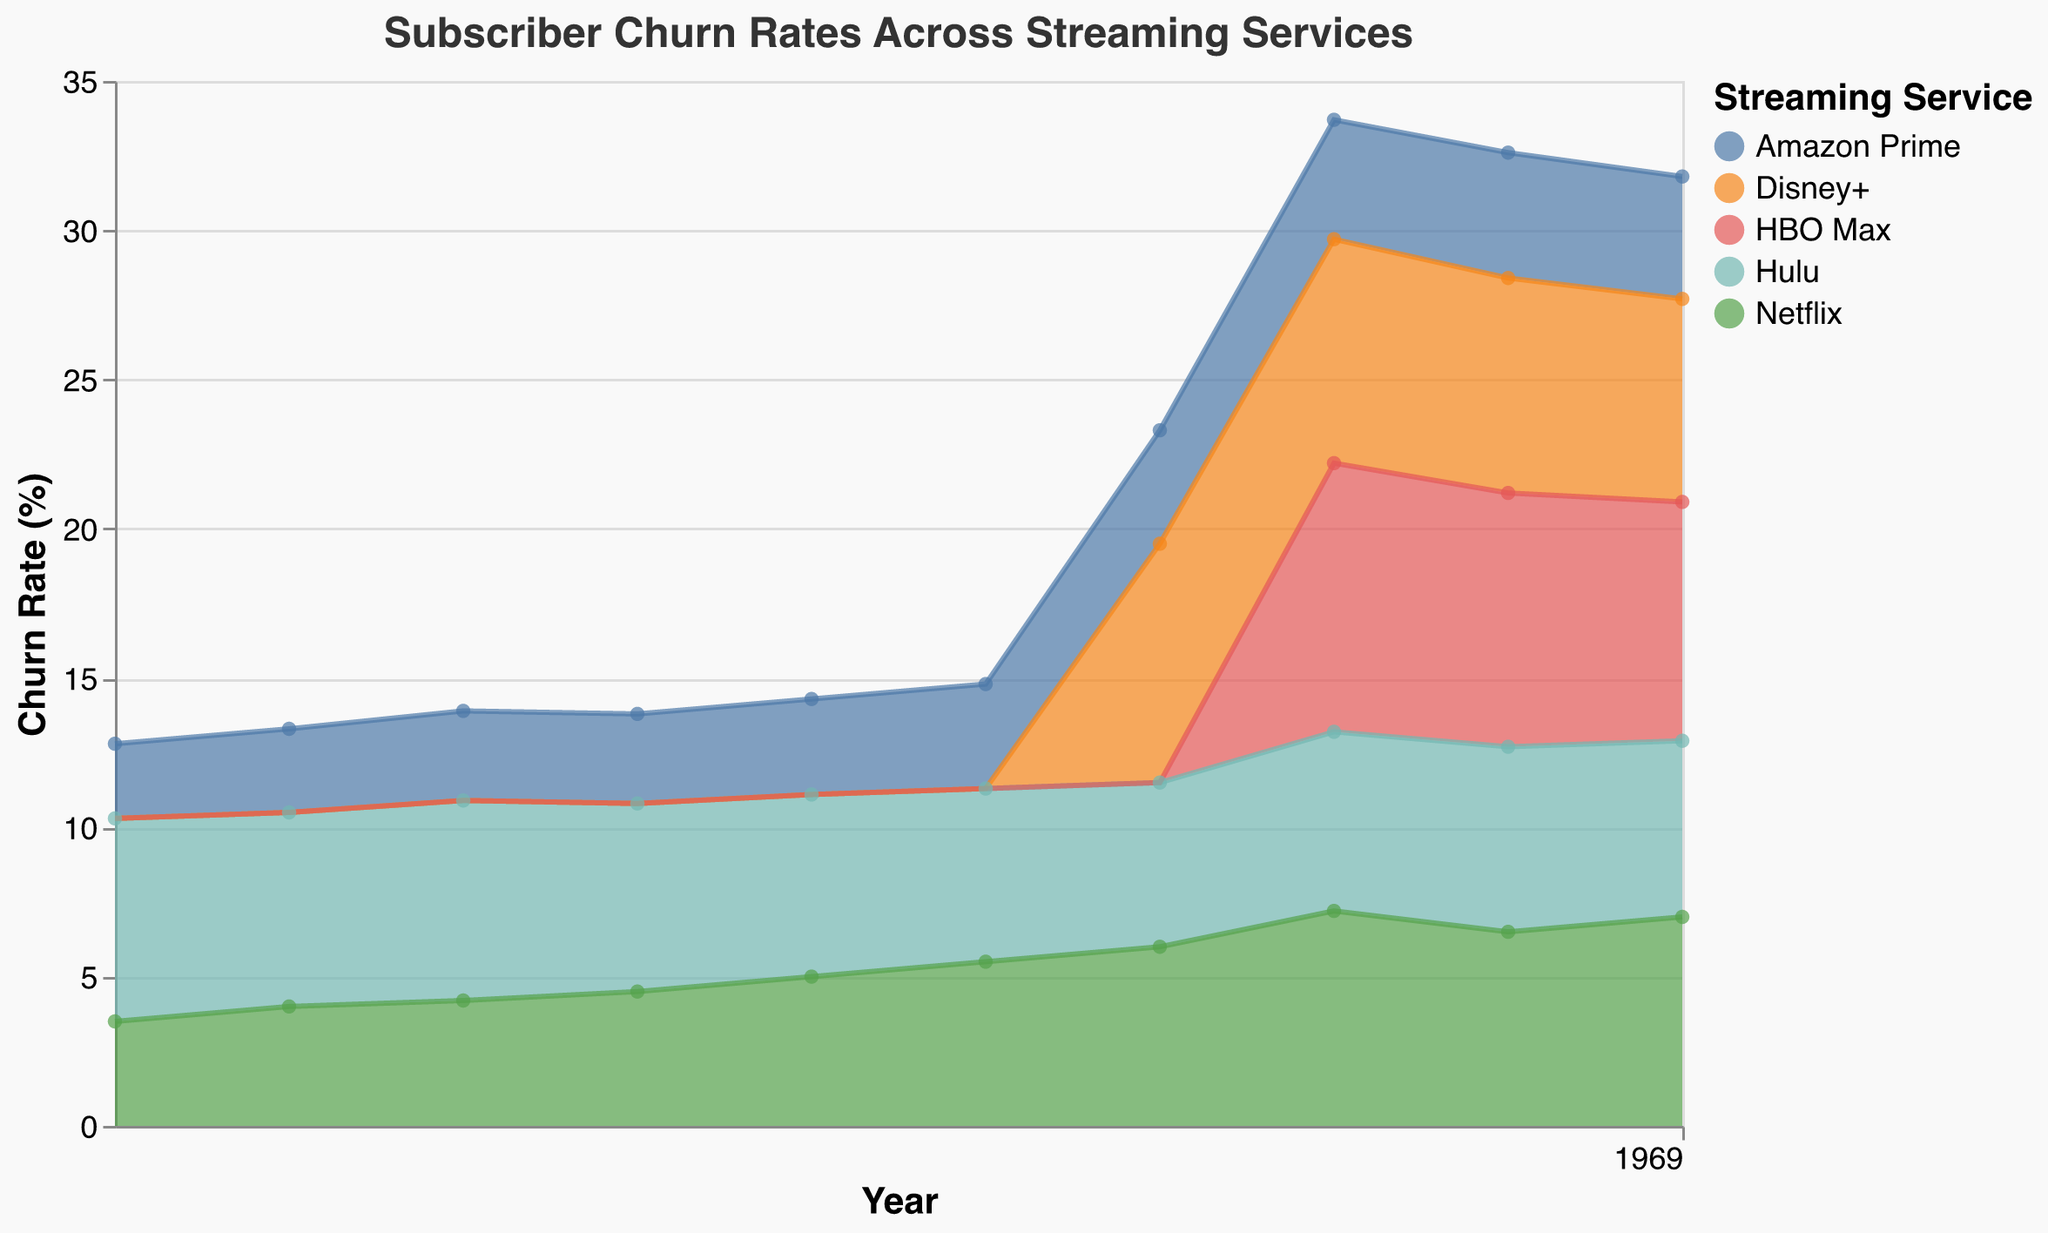What's the title of the area chart? The title is displayed prominently at the top of the chart. It reads "Subscriber Churn Rates Across Streaming Services," which provides an overview of what the chart is depicting.
Answer: Subscriber Churn Rates Across Streaming Services Which streaming service had the highest churn rate in 2020? By looking at the data points for the year 2020, HBO Max has the highest churn rate at 9.0%.
Answer: HBO Max What is the churn rate trend for Netflix from 2015 to 2020? Observing the trend line for Netflix from 2015 to 2020, the churn rate consistently increases: 4.2% in 2015, 4.5% in 2016, 5.0% in 2017, 5.5% in 2018, 6.0% in 2019, and 7.2% in 2020.
Answer: Increasing How did Disney+'s churn rate change from 2019 to 2022? Reviewing the data points for Disney+ from 2019 to 2022, the churn rate decreased from 8.0% in 2019 to 6.8% in 2022.
Answer: Decreased Which streaming service had the lowest churn rate in 2013? By examining the data for the year 2013, Amazon Prime had the lowest churn rate at 2.5%.
Answer: Amazon Prime What's the difference in churn rate between Hulu and Netflix in 2022? Looking at the churn rates for Hulu (5.9%) and Netflix (7.0%) in 2022, the difference is 7.0% - 5.9% = 1.1%.
Answer: 1.1% Compare the churn rates of Amazon Prime and Netflix in 2021. Which one had a higher churn rate? For the year 2021, Netflix had a churn rate of 6.5%, whereas Amazon Prime had a churn rate of 4.2%. Netflix's churn rate is higher.
Answer: Netflix What's the average churn rate for Hulu from 2013 to 2022? To find the average, sum all churn rates for Hulu from 2013 to 2022 and divide by the number of years: (6.8 + 6.5 + 6.7 + 6.3 + 6.1 + 5.8 + 5.5 + 6.0 + 6.2 + 5.9)/10 = 6.18%.
Answer: 6.18% Did HBO Max's churn rate increase or decrease between 2021 and 2022? By checking the data for HBO Max, the churn rate decreased from 8.5% in 2021 to 8.0% in 2022.
Answer: Decrease 